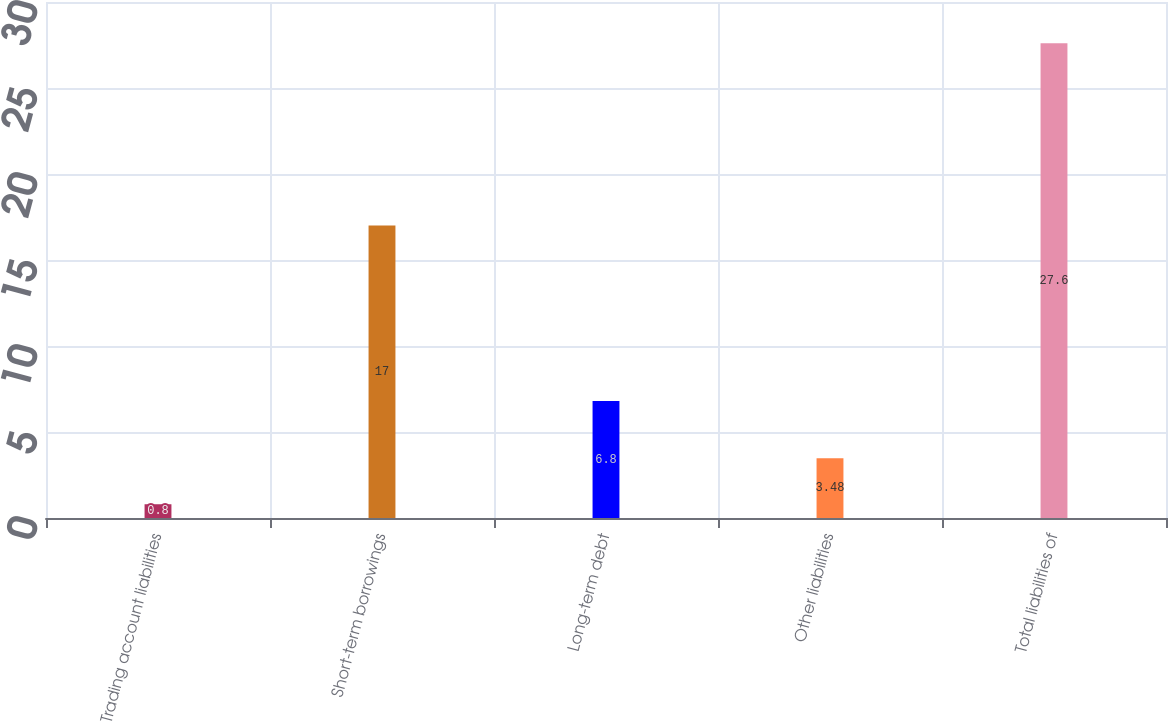<chart> <loc_0><loc_0><loc_500><loc_500><bar_chart><fcel>Trading account liabilities<fcel>Short-term borrowings<fcel>Long-term debt<fcel>Other liabilities<fcel>Total liabilities of<nl><fcel>0.8<fcel>17<fcel>6.8<fcel>3.48<fcel>27.6<nl></chart> 